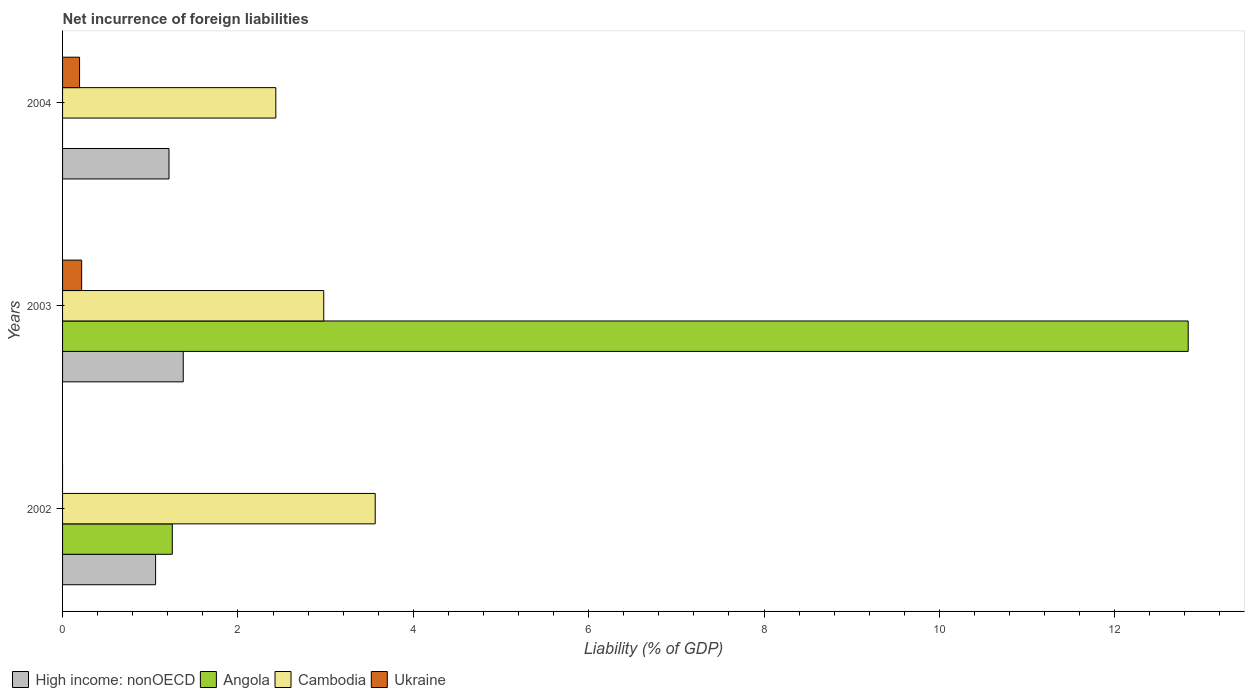How many groups of bars are there?
Your answer should be very brief. 3. Are the number of bars per tick equal to the number of legend labels?
Your response must be concise. No. Are the number of bars on each tick of the Y-axis equal?
Your answer should be very brief. No. How many bars are there on the 1st tick from the top?
Offer a very short reply. 3. How many bars are there on the 2nd tick from the bottom?
Provide a short and direct response. 4. What is the label of the 3rd group of bars from the top?
Provide a succinct answer. 2002. What is the net incurrence of foreign liabilities in Cambodia in 2004?
Provide a succinct answer. 2.43. Across all years, what is the maximum net incurrence of foreign liabilities in Cambodia?
Offer a very short reply. 3.57. Across all years, what is the minimum net incurrence of foreign liabilities in High income: nonOECD?
Your response must be concise. 1.06. What is the total net incurrence of foreign liabilities in High income: nonOECD in the graph?
Your answer should be compact. 3.65. What is the difference between the net incurrence of foreign liabilities in Angola in 2002 and that in 2003?
Offer a terse response. -11.59. What is the difference between the net incurrence of foreign liabilities in Angola in 2004 and the net incurrence of foreign liabilities in Ukraine in 2003?
Keep it short and to the point. -0.22. What is the average net incurrence of foreign liabilities in Cambodia per year?
Give a very brief answer. 2.99. In the year 2003, what is the difference between the net incurrence of foreign liabilities in Cambodia and net incurrence of foreign liabilities in Angola?
Your answer should be compact. -9.86. In how many years, is the net incurrence of foreign liabilities in Cambodia greater than 6.4 %?
Your response must be concise. 0. What is the ratio of the net incurrence of foreign liabilities in High income: nonOECD in 2003 to that in 2004?
Keep it short and to the point. 1.13. Is the net incurrence of foreign liabilities in High income: nonOECD in 2002 less than that in 2004?
Provide a succinct answer. Yes. What is the difference between the highest and the second highest net incurrence of foreign liabilities in Cambodia?
Offer a terse response. 0.59. What is the difference between the highest and the lowest net incurrence of foreign liabilities in High income: nonOECD?
Give a very brief answer. 0.32. In how many years, is the net incurrence of foreign liabilities in Cambodia greater than the average net incurrence of foreign liabilities in Cambodia taken over all years?
Your response must be concise. 1. Is it the case that in every year, the sum of the net incurrence of foreign liabilities in Ukraine and net incurrence of foreign liabilities in Cambodia is greater than the sum of net incurrence of foreign liabilities in High income: nonOECD and net incurrence of foreign liabilities in Angola?
Give a very brief answer. No. Is it the case that in every year, the sum of the net incurrence of foreign liabilities in High income: nonOECD and net incurrence of foreign liabilities in Cambodia is greater than the net incurrence of foreign liabilities in Ukraine?
Make the answer very short. Yes. Are the values on the major ticks of X-axis written in scientific E-notation?
Provide a short and direct response. No. Does the graph contain grids?
Keep it short and to the point. No. How many legend labels are there?
Ensure brevity in your answer.  4. How are the legend labels stacked?
Your answer should be compact. Horizontal. What is the title of the graph?
Offer a very short reply. Net incurrence of foreign liabilities. Does "Burundi" appear as one of the legend labels in the graph?
Give a very brief answer. No. What is the label or title of the X-axis?
Provide a short and direct response. Liability (% of GDP). What is the label or title of the Y-axis?
Your answer should be compact. Years. What is the Liability (% of GDP) of High income: nonOECD in 2002?
Provide a short and direct response. 1.06. What is the Liability (% of GDP) of Angola in 2002?
Ensure brevity in your answer.  1.25. What is the Liability (% of GDP) in Cambodia in 2002?
Your answer should be compact. 3.57. What is the Liability (% of GDP) of Ukraine in 2002?
Offer a terse response. 0. What is the Liability (% of GDP) in High income: nonOECD in 2003?
Your answer should be compact. 1.38. What is the Liability (% of GDP) in Angola in 2003?
Offer a terse response. 12.84. What is the Liability (% of GDP) of Cambodia in 2003?
Offer a very short reply. 2.98. What is the Liability (% of GDP) in Ukraine in 2003?
Give a very brief answer. 0.22. What is the Liability (% of GDP) of High income: nonOECD in 2004?
Offer a terse response. 1.21. What is the Liability (% of GDP) of Cambodia in 2004?
Provide a short and direct response. 2.43. What is the Liability (% of GDP) in Ukraine in 2004?
Give a very brief answer. 0.19. Across all years, what is the maximum Liability (% of GDP) of High income: nonOECD?
Provide a short and direct response. 1.38. Across all years, what is the maximum Liability (% of GDP) of Angola?
Give a very brief answer. 12.84. Across all years, what is the maximum Liability (% of GDP) in Cambodia?
Offer a very short reply. 3.57. Across all years, what is the maximum Liability (% of GDP) of Ukraine?
Your response must be concise. 0.22. Across all years, what is the minimum Liability (% of GDP) of High income: nonOECD?
Keep it short and to the point. 1.06. Across all years, what is the minimum Liability (% of GDP) in Cambodia?
Provide a short and direct response. 2.43. What is the total Liability (% of GDP) in High income: nonOECD in the graph?
Offer a very short reply. 3.65. What is the total Liability (% of GDP) in Angola in the graph?
Keep it short and to the point. 14.09. What is the total Liability (% of GDP) in Cambodia in the graph?
Give a very brief answer. 8.98. What is the total Liability (% of GDP) of Ukraine in the graph?
Make the answer very short. 0.41. What is the difference between the Liability (% of GDP) in High income: nonOECD in 2002 and that in 2003?
Ensure brevity in your answer.  -0.32. What is the difference between the Liability (% of GDP) of Angola in 2002 and that in 2003?
Provide a succinct answer. -11.59. What is the difference between the Liability (% of GDP) in Cambodia in 2002 and that in 2003?
Make the answer very short. 0.59. What is the difference between the Liability (% of GDP) in High income: nonOECD in 2002 and that in 2004?
Your answer should be very brief. -0.15. What is the difference between the Liability (% of GDP) of Cambodia in 2002 and that in 2004?
Provide a short and direct response. 1.13. What is the difference between the Liability (% of GDP) of High income: nonOECD in 2003 and that in 2004?
Your answer should be compact. 0.16. What is the difference between the Liability (% of GDP) of Cambodia in 2003 and that in 2004?
Provide a succinct answer. 0.55. What is the difference between the Liability (% of GDP) of Ukraine in 2003 and that in 2004?
Provide a succinct answer. 0.02. What is the difference between the Liability (% of GDP) of High income: nonOECD in 2002 and the Liability (% of GDP) of Angola in 2003?
Make the answer very short. -11.78. What is the difference between the Liability (% of GDP) in High income: nonOECD in 2002 and the Liability (% of GDP) in Cambodia in 2003?
Ensure brevity in your answer.  -1.92. What is the difference between the Liability (% of GDP) of High income: nonOECD in 2002 and the Liability (% of GDP) of Ukraine in 2003?
Provide a succinct answer. 0.84. What is the difference between the Liability (% of GDP) in Angola in 2002 and the Liability (% of GDP) in Cambodia in 2003?
Ensure brevity in your answer.  -1.73. What is the difference between the Liability (% of GDP) in Angola in 2002 and the Liability (% of GDP) in Ukraine in 2003?
Give a very brief answer. 1.03. What is the difference between the Liability (% of GDP) in Cambodia in 2002 and the Liability (% of GDP) in Ukraine in 2003?
Your answer should be compact. 3.35. What is the difference between the Liability (% of GDP) of High income: nonOECD in 2002 and the Liability (% of GDP) of Cambodia in 2004?
Your answer should be very brief. -1.37. What is the difference between the Liability (% of GDP) of High income: nonOECD in 2002 and the Liability (% of GDP) of Ukraine in 2004?
Provide a short and direct response. 0.87. What is the difference between the Liability (% of GDP) in Angola in 2002 and the Liability (% of GDP) in Cambodia in 2004?
Offer a very short reply. -1.18. What is the difference between the Liability (% of GDP) of Angola in 2002 and the Liability (% of GDP) of Ukraine in 2004?
Keep it short and to the point. 1.06. What is the difference between the Liability (% of GDP) in Cambodia in 2002 and the Liability (% of GDP) in Ukraine in 2004?
Provide a short and direct response. 3.37. What is the difference between the Liability (% of GDP) in High income: nonOECD in 2003 and the Liability (% of GDP) in Cambodia in 2004?
Provide a short and direct response. -1.06. What is the difference between the Liability (% of GDP) in High income: nonOECD in 2003 and the Liability (% of GDP) in Ukraine in 2004?
Your response must be concise. 1.18. What is the difference between the Liability (% of GDP) in Angola in 2003 and the Liability (% of GDP) in Cambodia in 2004?
Your response must be concise. 10.41. What is the difference between the Liability (% of GDP) in Angola in 2003 and the Liability (% of GDP) in Ukraine in 2004?
Give a very brief answer. 12.64. What is the difference between the Liability (% of GDP) in Cambodia in 2003 and the Liability (% of GDP) in Ukraine in 2004?
Your answer should be compact. 2.79. What is the average Liability (% of GDP) in High income: nonOECD per year?
Your answer should be very brief. 1.22. What is the average Liability (% of GDP) in Angola per year?
Provide a short and direct response. 4.7. What is the average Liability (% of GDP) of Cambodia per year?
Provide a short and direct response. 2.99. What is the average Liability (% of GDP) of Ukraine per year?
Your answer should be very brief. 0.14. In the year 2002, what is the difference between the Liability (% of GDP) of High income: nonOECD and Liability (% of GDP) of Angola?
Keep it short and to the point. -0.19. In the year 2002, what is the difference between the Liability (% of GDP) in High income: nonOECD and Liability (% of GDP) in Cambodia?
Give a very brief answer. -2.5. In the year 2002, what is the difference between the Liability (% of GDP) of Angola and Liability (% of GDP) of Cambodia?
Keep it short and to the point. -2.31. In the year 2003, what is the difference between the Liability (% of GDP) of High income: nonOECD and Liability (% of GDP) of Angola?
Offer a terse response. -11.46. In the year 2003, what is the difference between the Liability (% of GDP) of High income: nonOECD and Liability (% of GDP) of Cambodia?
Your answer should be compact. -1.6. In the year 2003, what is the difference between the Liability (% of GDP) in High income: nonOECD and Liability (% of GDP) in Ukraine?
Keep it short and to the point. 1.16. In the year 2003, what is the difference between the Liability (% of GDP) in Angola and Liability (% of GDP) in Cambodia?
Make the answer very short. 9.86. In the year 2003, what is the difference between the Liability (% of GDP) in Angola and Liability (% of GDP) in Ukraine?
Your answer should be very brief. 12.62. In the year 2003, what is the difference between the Liability (% of GDP) of Cambodia and Liability (% of GDP) of Ukraine?
Provide a succinct answer. 2.76. In the year 2004, what is the difference between the Liability (% of GDP) of High income: nonOECD and Liability (% of GDP) of Cambodia?
Offer a terse response. -1.22. In the year 2004, what is the difference between the Liability (% of GDP) in Cambodia and Liability (% of GDP) in Ukraine?
Your response must be concise. 2.24. What is the ratio of the Liability (% of GDP) of High income: nonOECD in 2002 to that in 2003?
Offer a very short reply. 0.77. What is the ratio of the Liability (% of GDP) of Angola in 2002 to that in 2003?
Your answer should be compact. 0.1. What is the ratio of the Liability (% of GDP) in Cambodia in 2002 to that in 2003?
Provide a succinct answer. 1.2. What is the ratio of the Liability (% of GDP) of High income: nonOECD in 2002 to that in 2004?
Provide a short and direct response. 0.87. What is the ratio of the Liability (% of GDP) of Cambodia in 2002 to that in 2004?
Your answer should be compact. 1.47. What is the ratio of the Liability (% of GDP) in High income: nonOECD in 2003 to that in 2004?
Offer a terse response. 1.13. What is the ratio of the Liability (% of GDP) in Cambodia in 2003 to that in 2004?
Provide a succinct answer. 1.22. What is the ratio of the Liability (% of GDP) of Ukraine in 2003 to that in 2004?
Offer a very short reply. 1.12. What is the difference between the highest and the second highest Liability (% of GDP) of High income: nonOECD?
Offer a very short reply. 0.16. What is the difference between the highest and the second highest Liability (% of GDP) in Cambodia?
Keep it short and to the point. 0.59. What is the difference between the highest and the lowest Liability (% of GDP) of High income: nonOECD?
Your answer should be very brief. 0.32. What is the difference between the highest and the lowest Liability (% of GDP) of Angola?
Ensure brevity in your answer.  12.84. What is the difference between the highest and the lowest Liability (% of GDP) in Cambodia?
Offer a very short reply. 1.13. What is the difference between the highest and the lowest Liability (% of GDP) in Ukraine?
Make the answer very short. 0.22. 